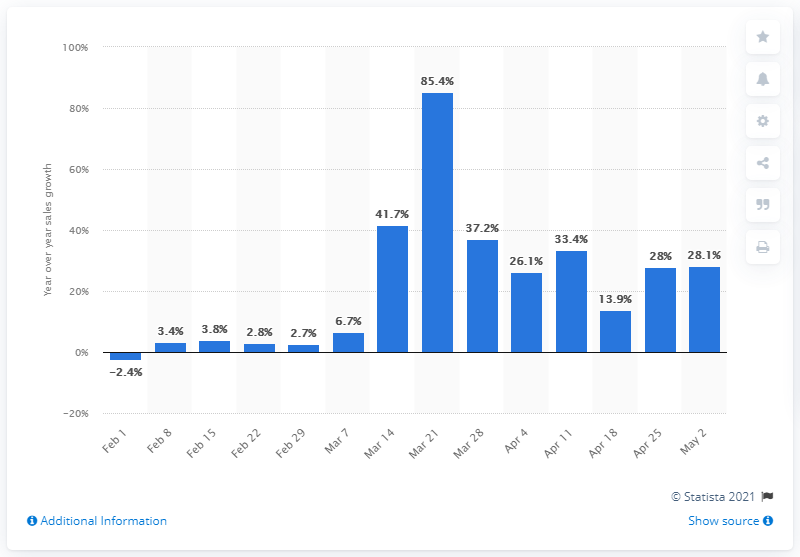Indicate a few pertinent items in this graphic. The retail food sales in the week ending March 21, 2020, increased by 85.4% compared to the previous week. 